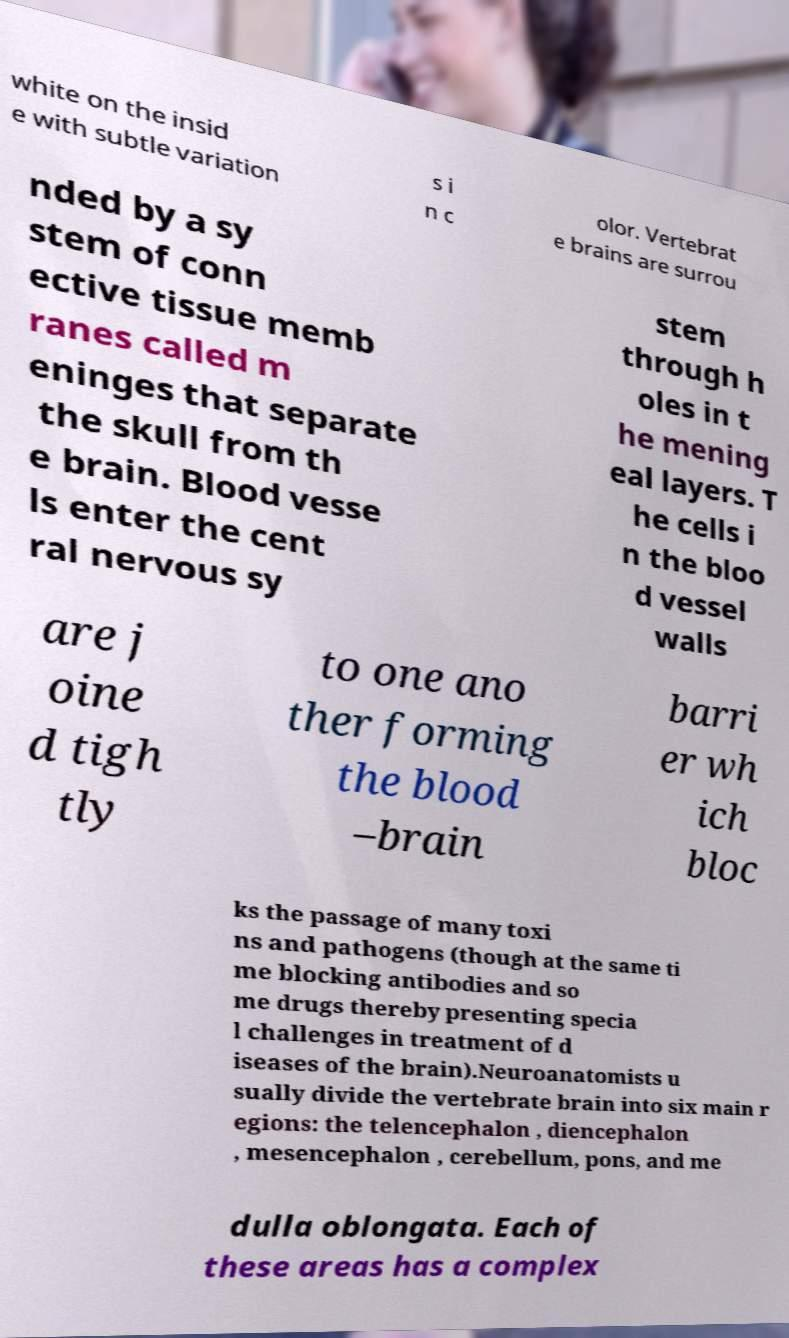Could you assist in decoding the text presented in this image and type it out clearly? white on the insid e with subtle variation s i n c olor. Vertebrat e brains are surrou nded by a sy stem of conn ective tissue memb ranes called m eninges that separate the skull from th e brain. Blood vesse ls enter the cent ral nervous sy stem through h oles in t he mening eal layers. T he cells i n the bloo d vessel walls are j oine d tigh tly to one ano ther forming the blood –brain barri er wh ich bloc ks the passage of many toxi ns and pathogens (though at the same ti me blocking antibodies and so me drugs thereby presenting specia l challenges in treatment of d iseases of the brain).Neuroanatomists u sually divide the vertebrate brain into six main r egions: the telencephalon , diencephalon , mesencephalon , cerebellum, pons, and me dulla oblongata. Each of these areas has a complex 